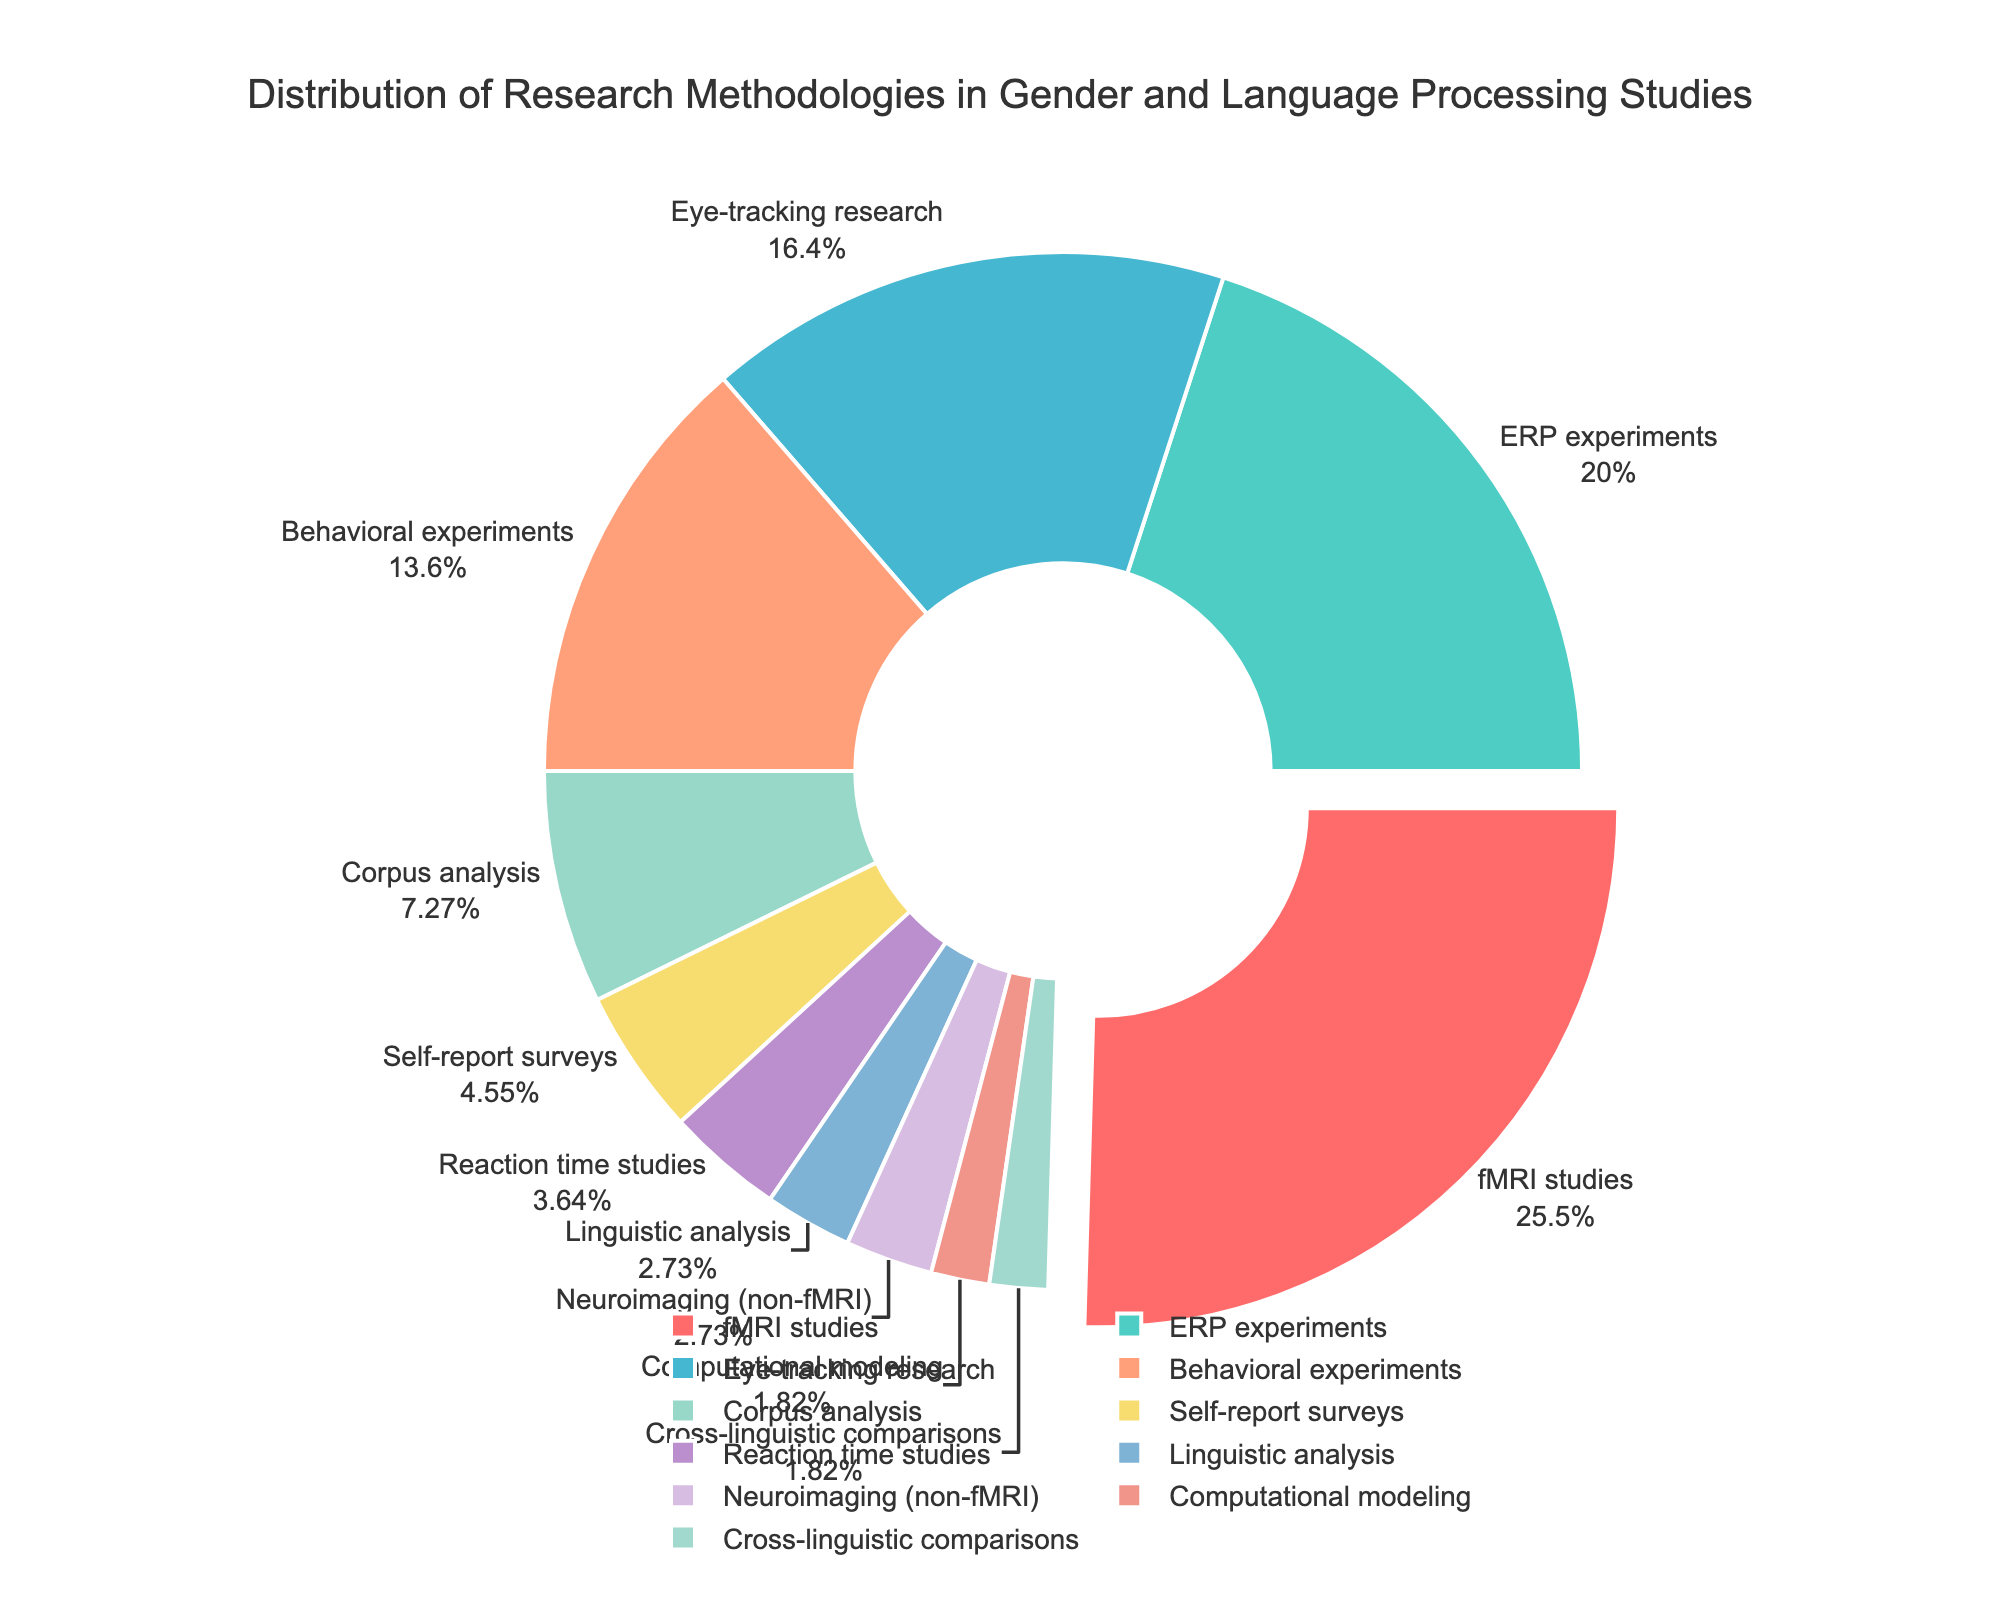What is the most commonly used research methodology? The pie chart highlights different methodologies with segments whose size and percentage annotations indicate their usage. The largest segment and the one pulled out slightly (highlighted) represent fMRI studies, which have the largest percentage at 28%.
Answer: fMRI studies Which two methodologies have the least usage, and what are their combined percentages? The smallest segments listed at 2% each represent Computational modeling and Cross-linguistic comparisons. To find their combined percentage, add 2% + 2% = 4%.
Answer: Computational modeling and Cross-linguistic comparisons, 4% What is the total percentage of neuroimaging-related methodologies (fMRI and Neuroimaging (non-fMRI))? From the pie chart, we see that fMRI studies represent 28%, and Neuroimaging (non-fMRI) represents 3%. Adding these together gives 28% + 3% = 31%.
Answer: 31% How does the percentage of ERP experiments compare to Eye-tracking research? The pie chart shows ERP experiments at 22% and Eye-tracking research at 18%. ERP experiments have a higher percentage compared to Eye-tracking research.
Answer: ERP experiments have 4% more than Eye-tracking research Which methodology is represented by a blue segment, and what is its percentage? The pie chart uses different colors for each methodology segment. The Eye-tracking research is represented by the blue-colored segment, which is labeled as 18%.
Answer: Eye-tracking research, 18% What is the combined percentage of Behavioral experiments and Self-report surveys? From the pie chart, Behavioral experiments are at 15% and Self-report surveys at 5%. Their combined percentage is 15% + 5% = 20%.
Answer: 20% Which has a higher percentage: Corpus analysis or Reaction time studies, and by how much? The pie chart shows Corpus analysis at 8% and Reaction time studies at 4%. Corpus analysis has a higher percentage. The difference is 8% - 4% = 4%.
Answer: Corpus analysis by 4% What is the combined percentage of the three least common methodologies? The least common methodologies from the pie chart are Computational modeling (2%), Cross-linguistic comparisons (2%), and Linguistic analysis (3%). Their combined percentage is 2% + 2% + 3% = 7%.
Answer: 7% What is the percentage difference between the methodology with the highest usage and the methodology with the lowest usage? From the pie chart, the methodology with the highest usage is fMRI studies at 28%, and the lowest are Computational modeling and Cross-linguistic comparisons, each at 2%. The difference is 28% - 2% = 26%.
Answer: 26% Which methodology's segment follows immediately after fMRI studies in a clockwise direction? Observing the pie chart, which is organized clockwise starting from the top, the segment following the largest (fMRI studies) is labeled ERP experiments at 22%.
Answer: ERP experiments 